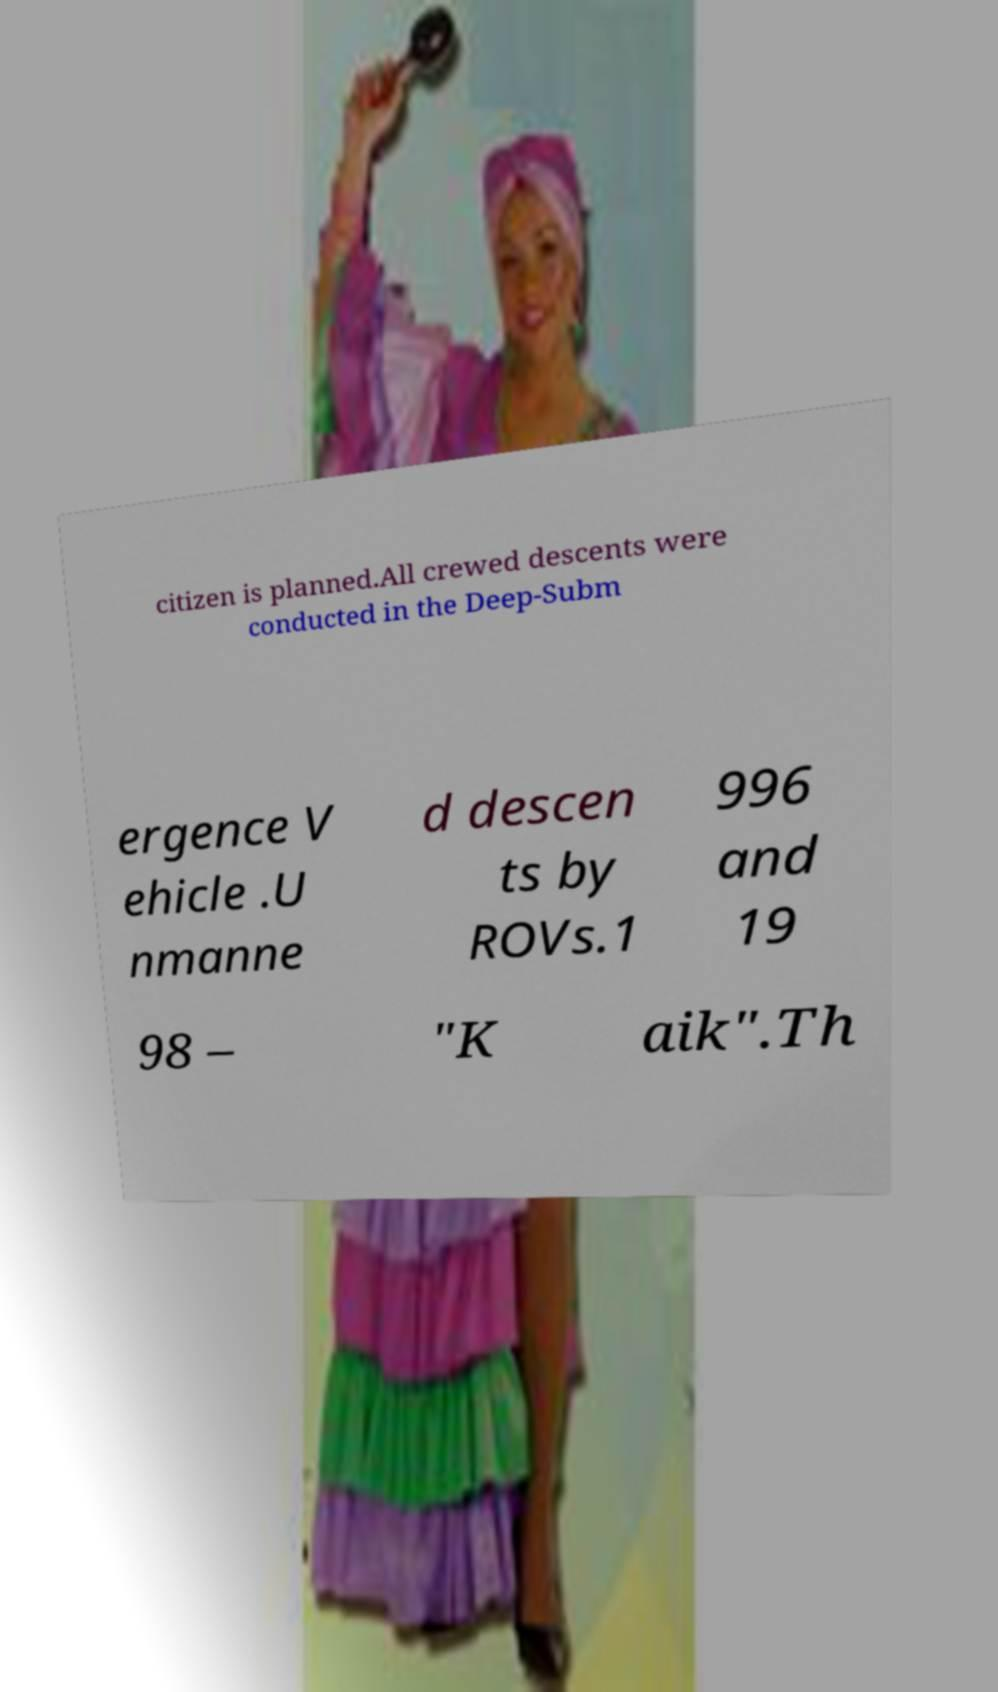What messages or text are displayed in this image? I need them in a readable, typed format. citizen is planned.All crewed descents were conducted in the Deep-Subm ergence V ehicle .U nmanne d descen ts by ROVs.1 996 and 19 98 – "K aik".Th 